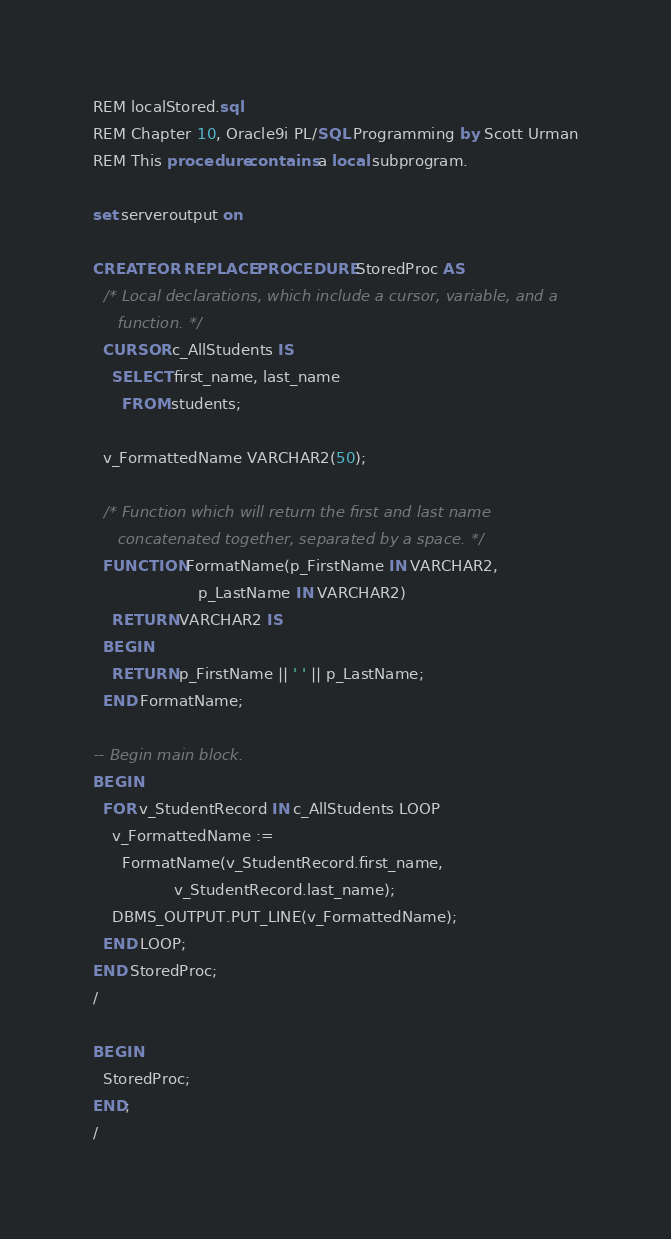<code> <loc_0><loc_0><loc_500><loc_500><_SQL_>REM localStored.sql
REM Chapter 10, Oracle9i PL/SQL Programming by Scott Urman
REM This procedure contains a local subprogram.

set serveroutput on

CREATE OR REPLACE PROCEDURE StoredProc AS
  /* Local declarations, which include a cursor, variable, and a
     function. */
  CURSOR c_AllStudents IS
    SELECT first_name, last_name
      FROM students;

  v_FormattedName VARCHAR2(50);

  /* Function which will return the first and last name
     concatenated together, separated by a space. */
  FUNCTION FormatName(p_FirstName IN VARCHAR2,
                      p_LastName IN VARCHAR2)
    RETURN VARCHAR2 IS
  BEGIN
    RETURN p_FirstName || ' ' || p_LastName;
  END FormatName;

-- Begin main block.
BEGIN
  FOR v_StudentRecord IN c_AllStudents LOOP
    v_FormattedName :=
      FormatName(v_StudentRecord.first_name,
                 v_StudentRecord.last_name);
    DBMS_OUTPUT.PUT_LINE(v_FormattedName);
  END LOOP;
END StoredProc;
/

BEGIN
  StoredProc;
END;
/
</code> 